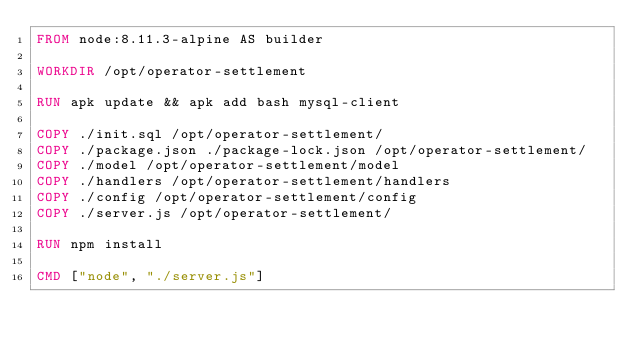Convert code to text. <code><loc_0><loc_0><loc_500><loc_500><_Dockerfile_>FROM node:8.11.3-alpine AS builder

WORKDIR /opt/operator-settlement

RUN apk update && apk add bash mysql-client

COPY ./init.sql /opt/operator-settlement/
COPY ./package.json ./package-lock.json /opt/operator-settlement/
COPY ./model /opt/operator-settlement/model
COPY ./handlers /opt/operator-settlement/handlers
COPY ./config /opt/operator-settlement/config
COPY ./server.js /opt/operator-settlement/

RUN npm install

CMD ["node", "./server.js"]
</code> 